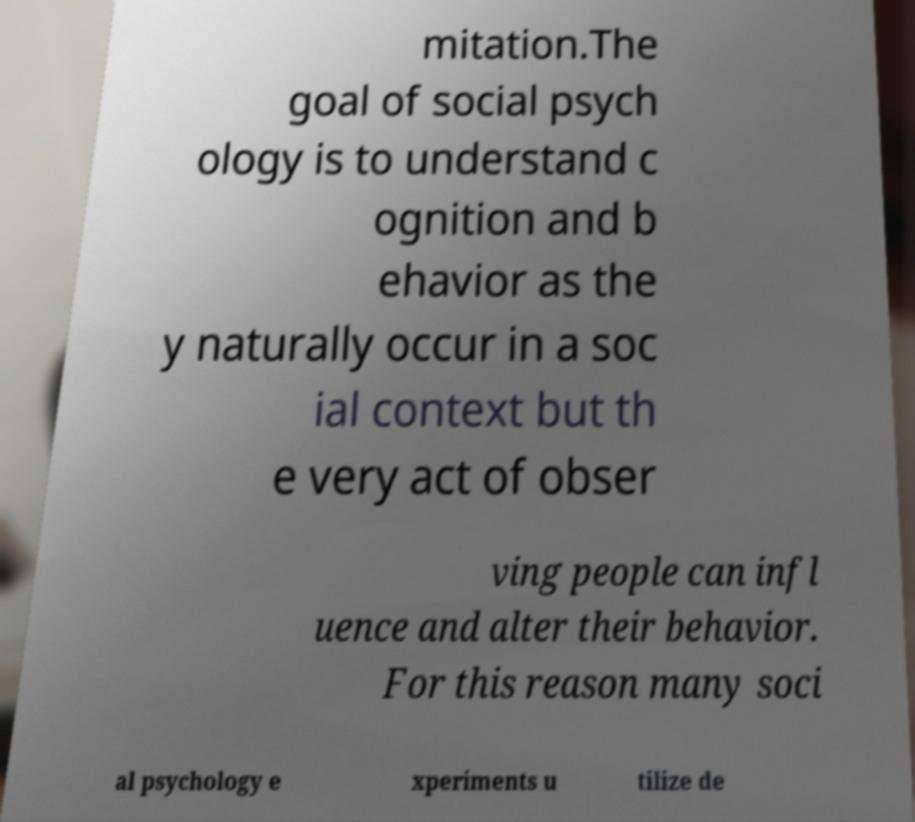Can you accurately transcribe the text from the provided image for me? mitation.The goal of social psych ology is to understand c ognition and b ehavior as the y naturally occur in a soc ial context but th e very act of obser ving people can infl uence and alter their behavior. For this reason many soci al psychology e xperiments u tilize de 